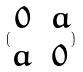Convert formula to latex. <formula><loc_0><loc_0><loc_500><loc_500>( \begin{matrix} 0 & a \\ a & 0 \end{matrix} )</formula> 